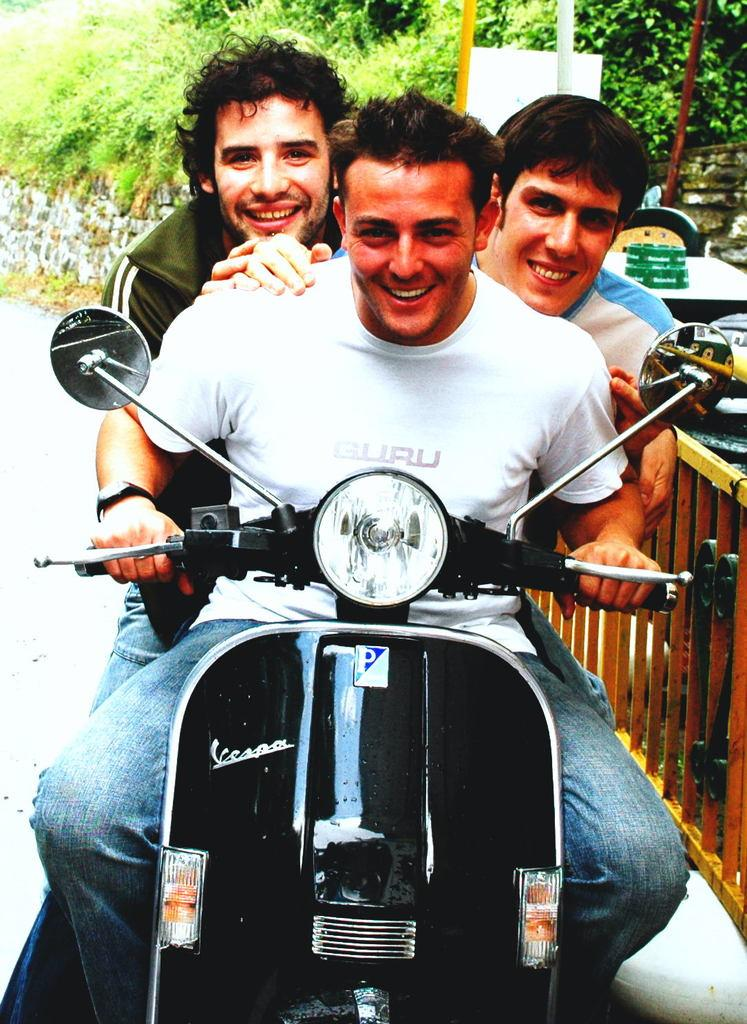How many people are in the image? There are three men in the image. What are the men doing in the image? The men are sitting on a scooter. What can be seen in the background of the image? There are trees visible in the background of the image. What type of arithmetic problem is the minister solving in the image? There is no minister or arithmetic problem present in the image. How does the scooter contribute to pollution in the image? The image does not provide information about the scooter's impact on pollution. 